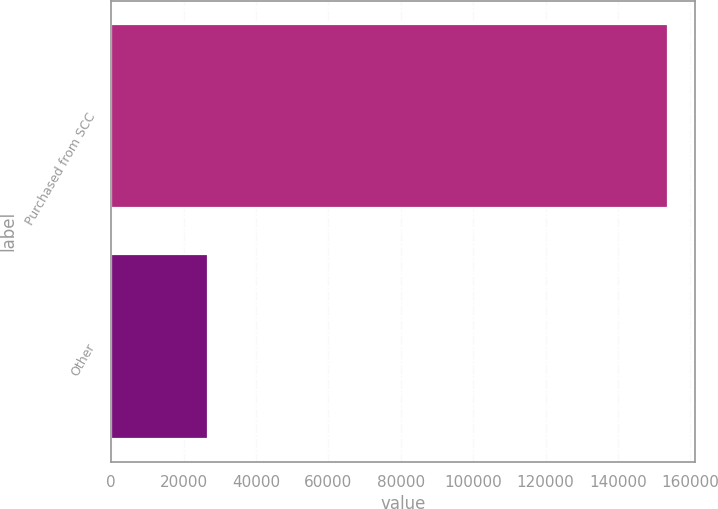Convert chart. <chart><loc_0><loc_0><loc_500><loc_500><bar_chart><fcel>Purchased from SCC<fcel>Other<nl><fcel>153719<fcel>26821<nl></chart> 